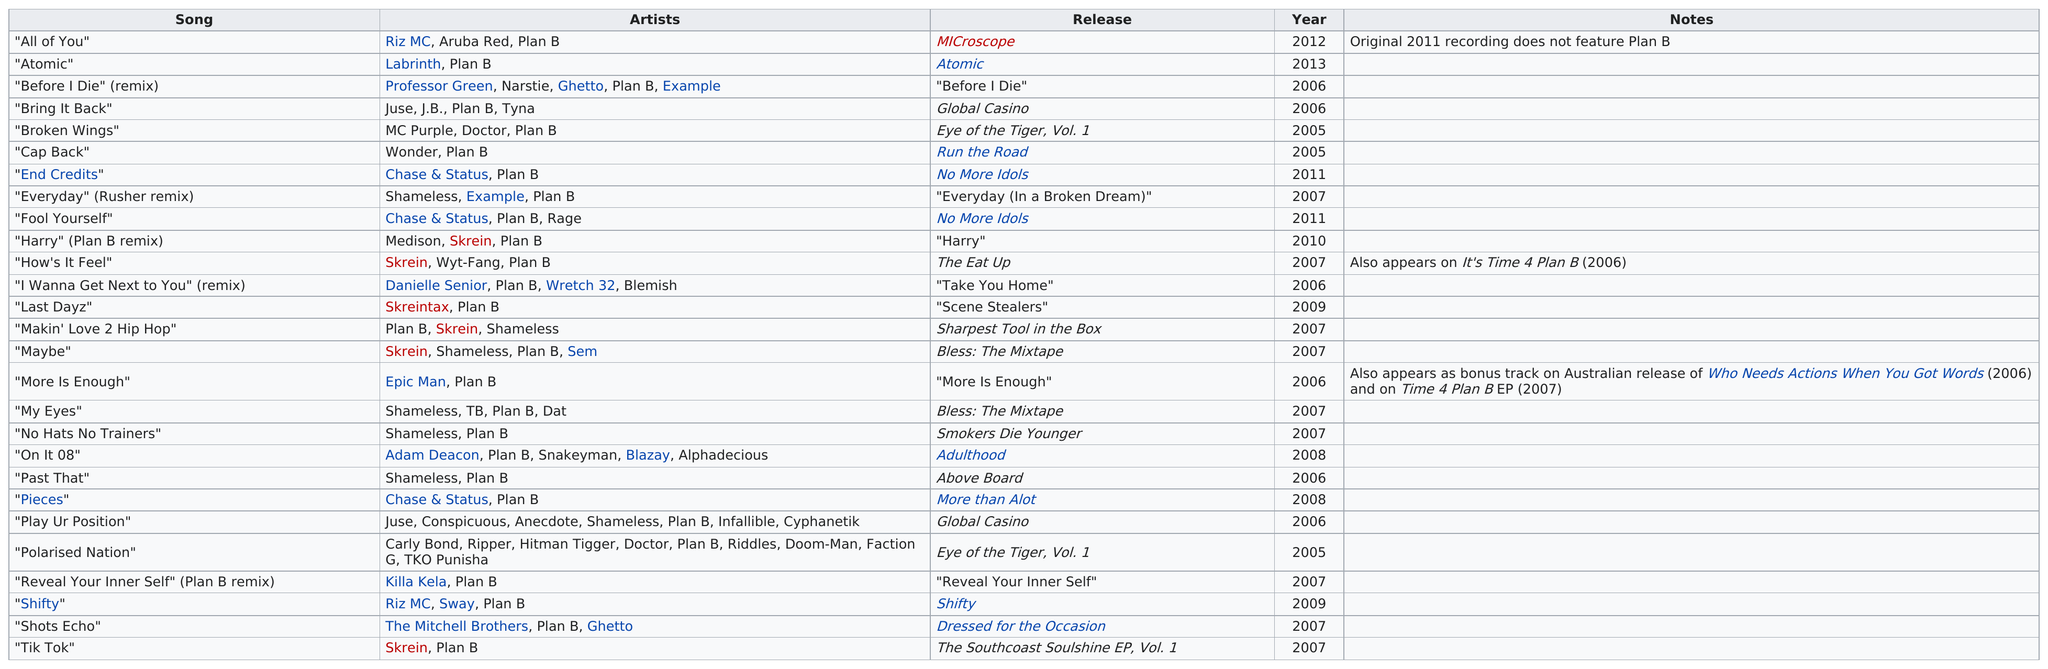Highlight a few significant elements in this photo. Polarised Nation" is a song with the most number of artists performing on it, making it a testament to the collaborative spirit of the music industry. The first song was released in 2005. Skrein was listed as an artist on a song five times. The next song listed after "Cap Back" is "End Credits. Shameless performed a total of 7 songs. 